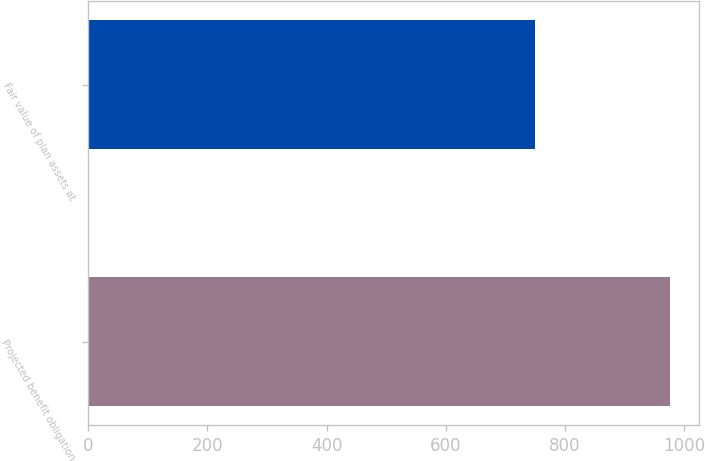Convert chart. <chart><loc_0><loc_0><loc_500><loc_500><bar_chart><fcel>Projected benefit obligation<fcel>Fair value of plan assets at<nl><fcel>976<fcel>749<nl></chart> 